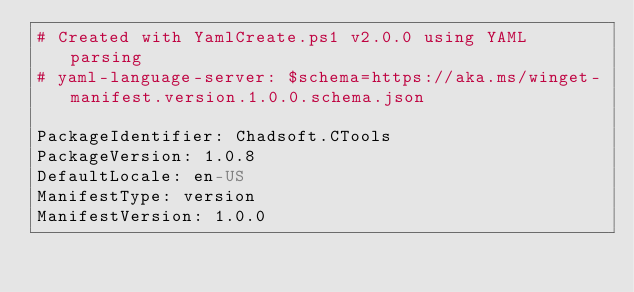Convert code to text. <code><loc_0><loc_0><loc_500><loc_500><_YAML_># Created with YamlCreate.ps1 v2.0.0 using YAML parsing
# yaml-language-server: $schema=https://aka.ms/winget-manifest.version.1.0.0.schema.json

PackageIdentifier: Chadsoft.CTools
PackageVersion: 1.0.8
DefaultLocale: en-US
ManifestType: version
ManifestVersion: 1.0.0
</code> 